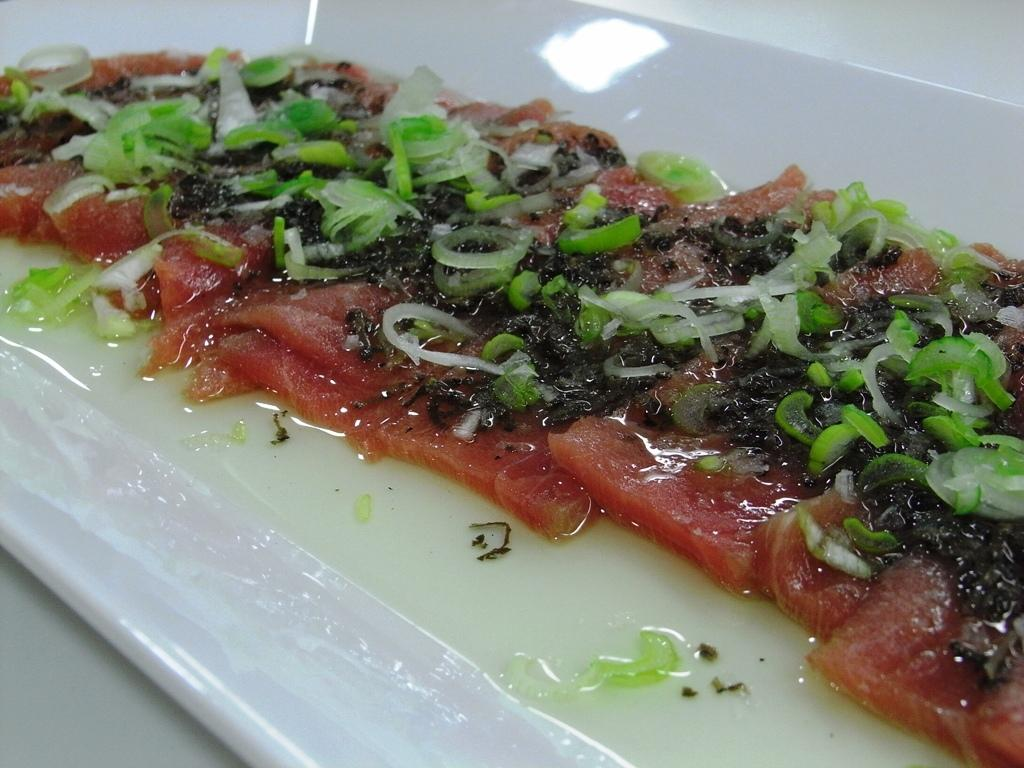What color is the plate in the image? The plate in the image is white colored. What is on the plate? There is a food item on the plate. Can you describe the colors of the food item? The food item has green, black, and brown colors. What type of hill can be seen in the background of the image? There is no hill visible in the image; it only features a white colored plate with a food item on it. 